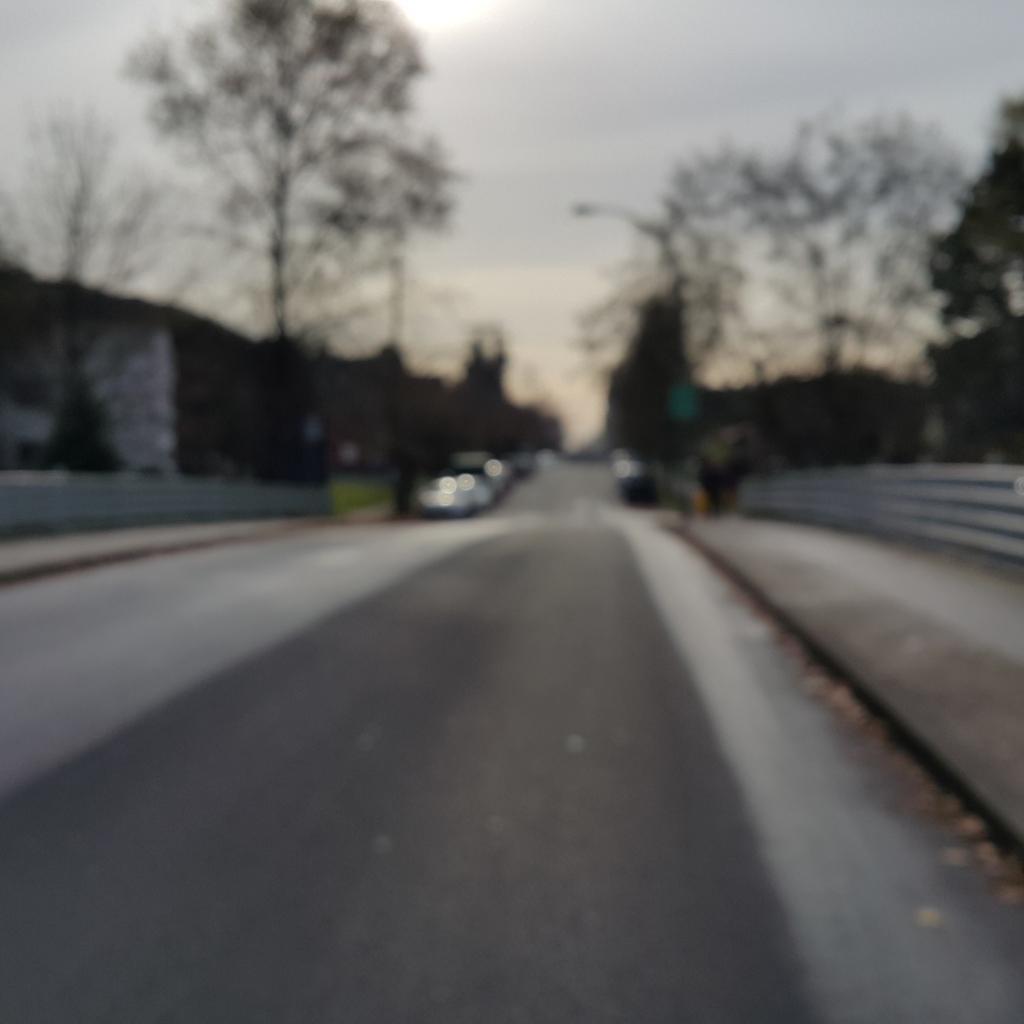How would you summarize this image in a sentence or two? In the foreground of the picture I can see the road. I can see the fence on both sides of the road. There are vehicles on the road. I can see a house on the left side. There are trees on both sides of the road. There are clouds in the sky. 